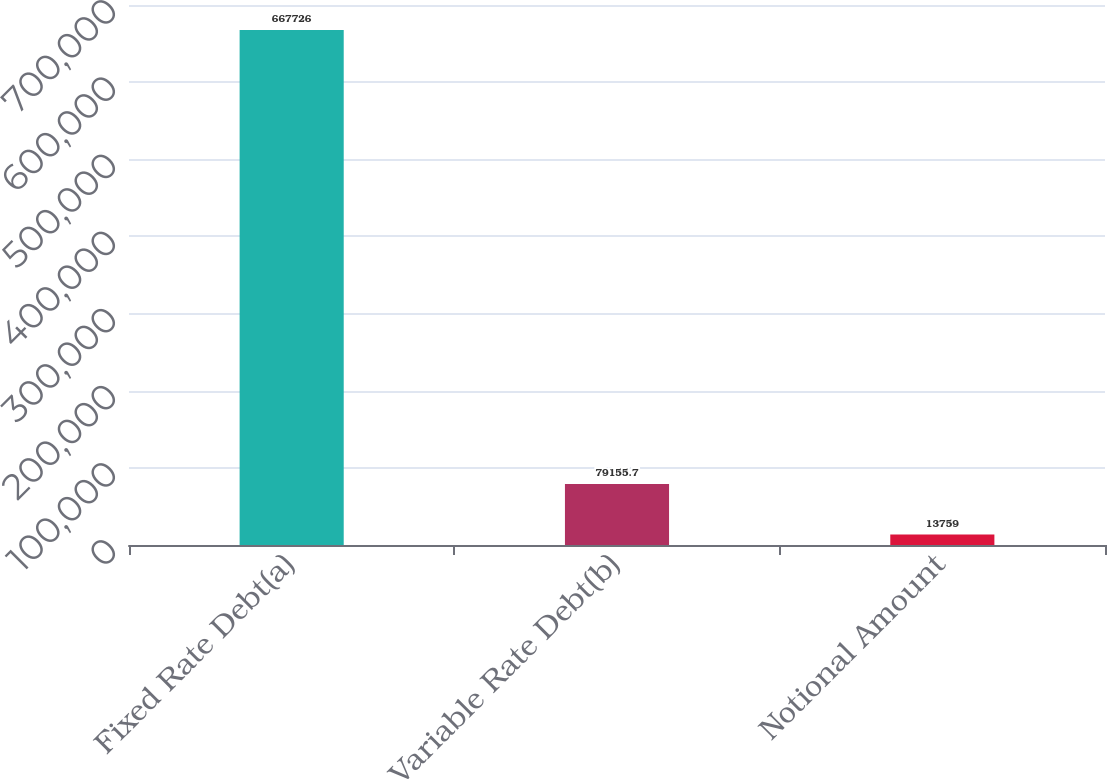Convert chart to OTSL. <chart><loc_0><loc_0><loc_500><loc_500><bar_chart><fcel>Fixed Rate Debt(a)<fcel>Variable Rate Debt(b)<fcel>Notional Amount<nl><fcel>667726<fcel>79155.7<fcel>13759<nl></chart> 